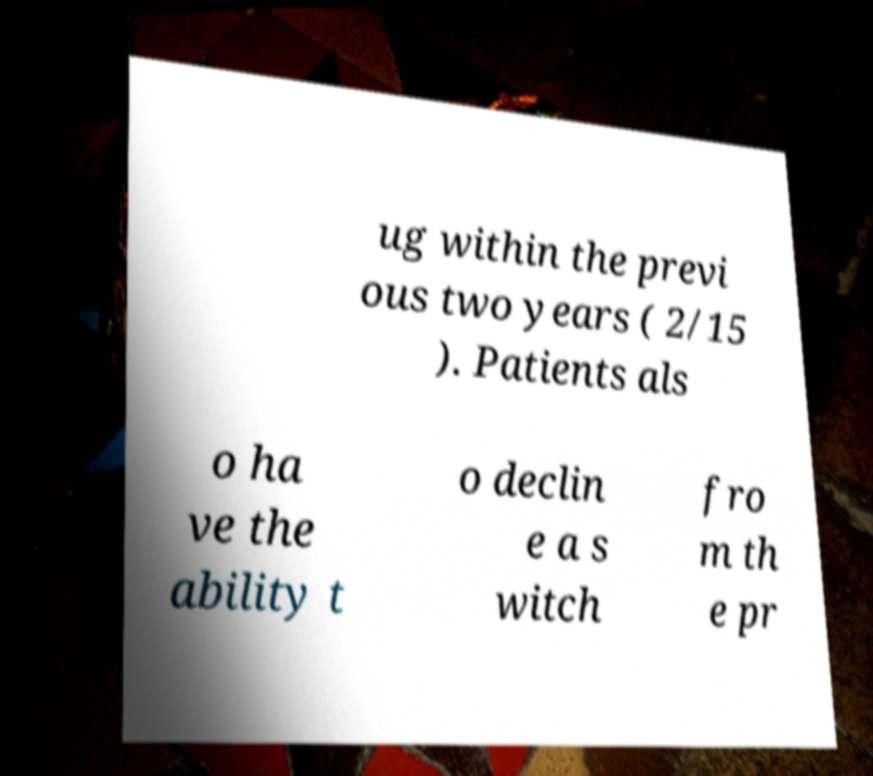For documentation purposes, I need the text within this image transcribed. Could you provide that? ug within the previ ous two years ( 2/15 ). Patients als o ha ve the ability t o declin e a s witch fro m th e pr 